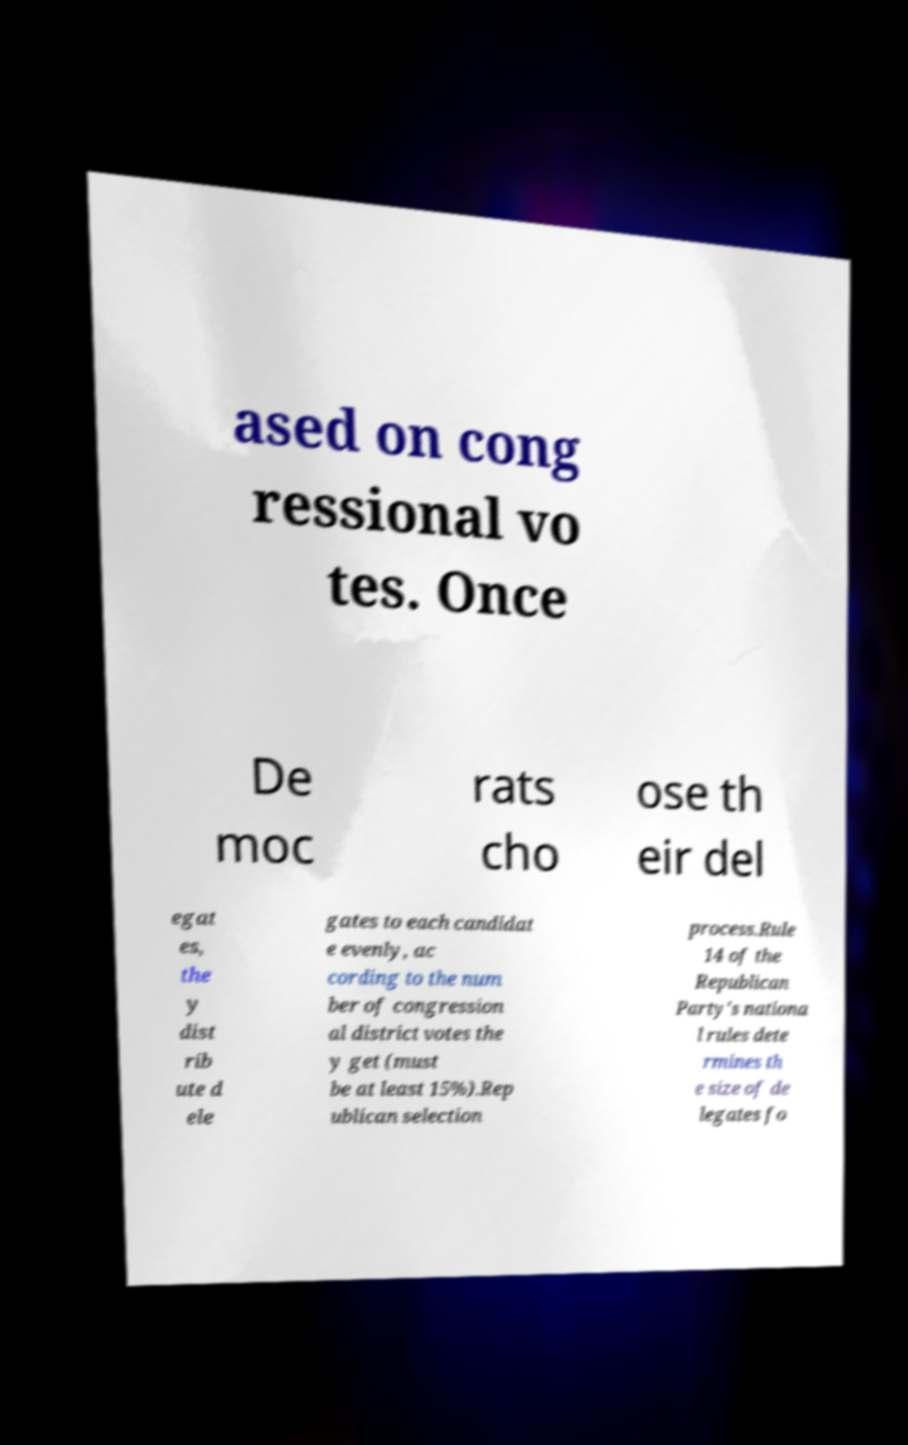Can you accurately transcribe the text from the provided image for me? ased on cong ressional vo tes. Once De moc rats cho ose th eir del egat es, the y dist rib ute d ele gates to each candidat e evenly, ac cording to the num ber of congression al district votes the y get (must be at least 15%).Rep ublican selection process.Rule 14 of the Republican Party's nationa l rules dete rmines th e size of de legates fo 